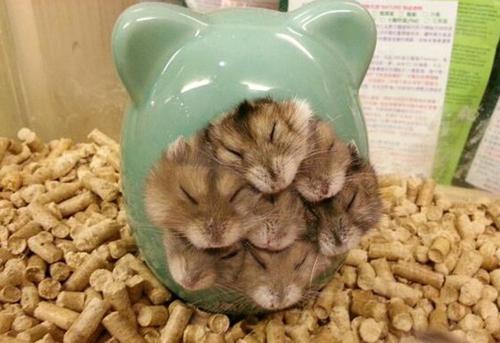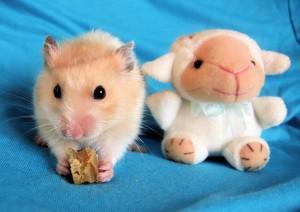The first image is the image on the left, the second image is the image on the right. Given the left and right images, does the statement "The right image contains at least one rodent standing on a blue cloth." hold true? Answer yes or no. Yes. 